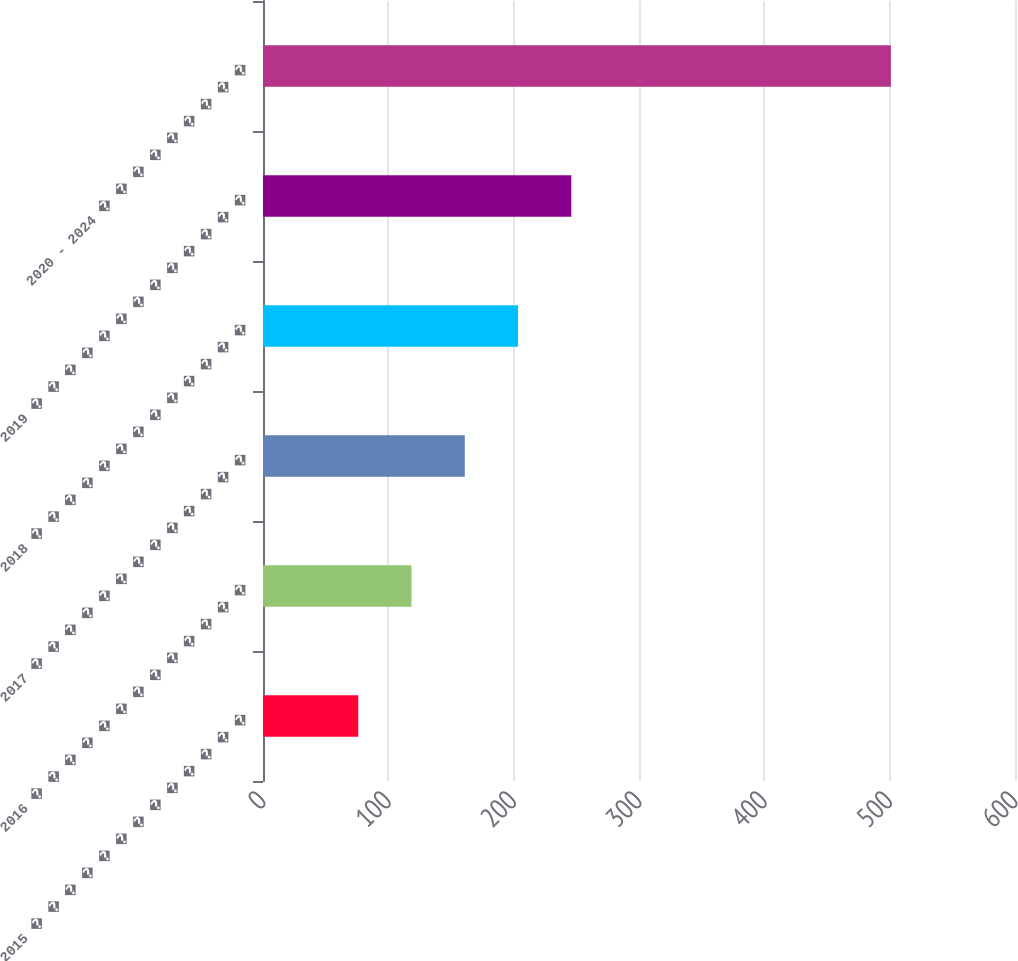<chart> <loc_0><loc_0><loc_500><loc_500><bar_chart><fcel>2015 � � � � � � � � � � � � �<fcel>2016 � � � � � � � � � � � � �<fcel>2017 � � � � � � � � � � � � �<fcel>2018 � � � � � � � � � � � � �<fcel>2019 � � � � � � � � � � � � �<fcel>2020 - 2024 � � � � � � � � �<nl><fcel>76<fcel>118.5<fcel>161<fcel>203.5<fcel>246<fcel>501<nl></chart> 